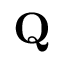Convert formula to latex. <formula><loc_0><loc_0><loc_500><loc_500>Q</formula> 